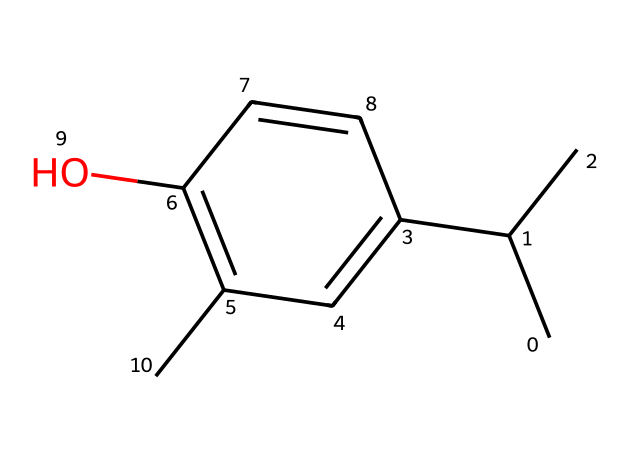What is the name of this chemical? This chemical corresponds to the structure commonly known as "α-terpineol". The SMILES provided represents its molecular structure, which can be verified by comparing its bonds and functional groups with known standards.
Answer: α-terpineol How many chiral centers does this compound have? The compound has one chiral center, which is determined by identifying the carbon atom that is attached to four different substituents. In this structure, this is clear from the arrangement around the carbon in the cyclohexene ring.
Answer: one What is the molecular formula of this compound? To derive the molecular formula, count the number of carbon (C), hydrogen (H), and oxygen (O) atoms present in the structure. This compound contains 10 carbon atoms, 18 hydrogen atoms, and 1 oxygen atom, leading to the formula C10H18O.
Answer: C10H18O What functional groups are present in this compound? The main functional group in this structure is an alcohol (indicated by the -OH group), while there is also an alkene (due to the double bond in the ring). The presence of these functional groups can be identified from their characteristic structures within the chemical.
Answer: alcohol, alkene Is this compound optically active? Yes, this compound is optically active due to the presence of a chiral center, as evidenced by the presence of substituents around the chiral carbon, which can lead to non-superimposable mirror images. This defines optical activity.
Answer: yes 